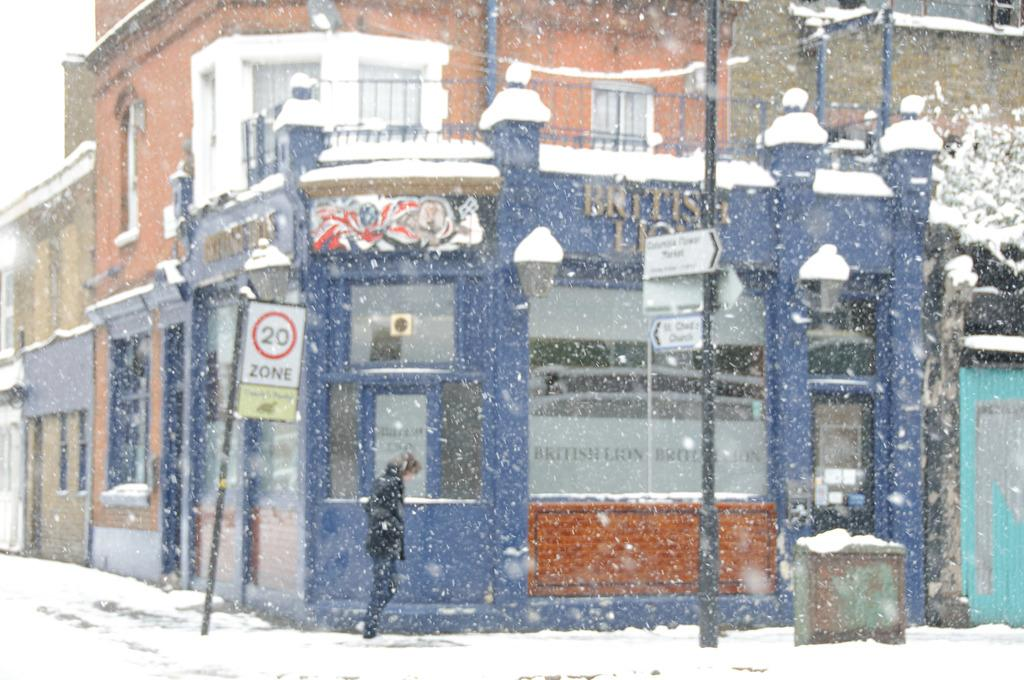What type of structures can be seen in the image? There are buildings in the image. What is the woman doing in the image? A woman is walking on the snow in front of a building. Are there any indications of businesses or locations in the image? Yes, there are sign boards visible in the image. How many cars are parked in front of the building in the image? There are no cars visible in the image; the woman is walking on the snow in front of a building. 